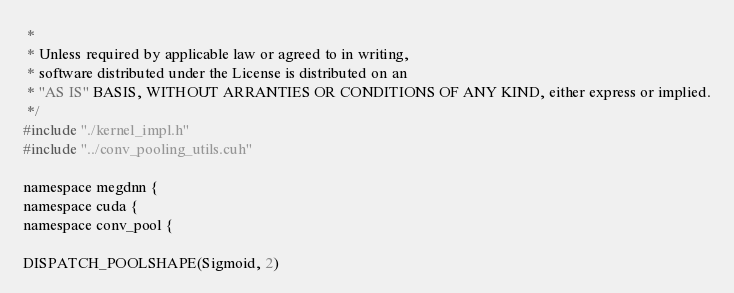<code> <loc_0><loc_0><loc_500><loc_500><_Cuda_> *
 * Unless required by applicable law or agreed to in writing,
 * software distributed under the License is distributed on an
 * "AS IS" BASIS, WITHOUT ARRANTIES OR CONDITIONS OF ANY KIND, either express or implied.
 */
#include "./kernel_impl.h"
#include "../conv_pooling_utils.cuh"

namespace megdnn {
namespace cuda {
namespace conv_pool {

DISPATCH_POOLSHAPE(Sigmoid, 2)
</code> 